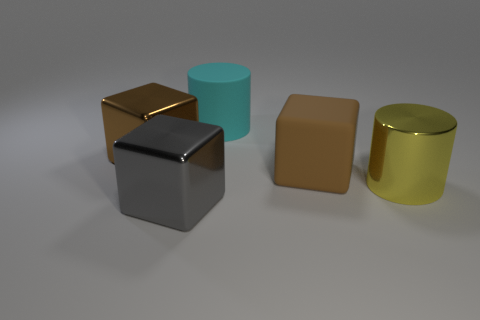What is the shape of the large metallic thing to the left of the big block in front of the large cylinder that is in front of the cyan cylinder?
Ensure brevity in your answer.  Cube. There is a big metal object right of the brown cube on the right side of the cyan cylinder; what shape is it?
Your answer should be compact. Cylinder. Is there another gray block made of the same material as the gray block?
Provide a succinct answer. No. There is a metal block that is the same color as the large matte cube; what is its size?
Your answer should be compact. Large. How many brown objects are rubber balls or metal cubes?
Offer a terse response. 1. Is there a block of the same color as the big matte cylinder?
Ensure brevity in your answer.  No. The gray object that is the same material as the large yellow cylinder is what size?
Ensure brevity in your answer.  Large. How many cylinders are cyan rubber objects or big shiny objects?
Provide a short and direct response. 2. Is the number of large brown matte cubes greater than the number of big matte objects?
Offer a terse response. No. How many brown rubber blocks have the same size as the yellow cylinder?
Keep it short and to the point. 1. 